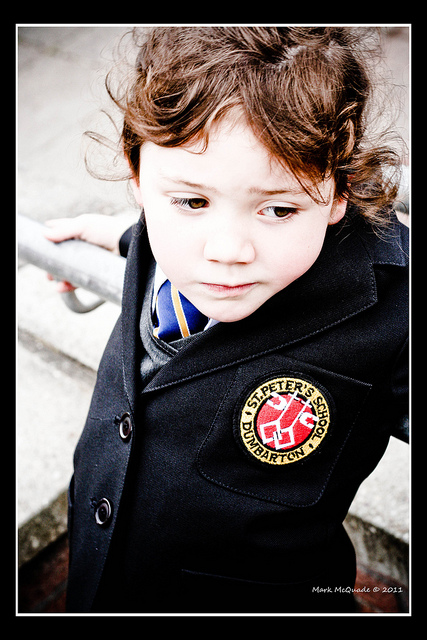Identify the text displayed in this image. ST. PETER'S SCHOOL DUMBARTON Mark McQuade 2011 